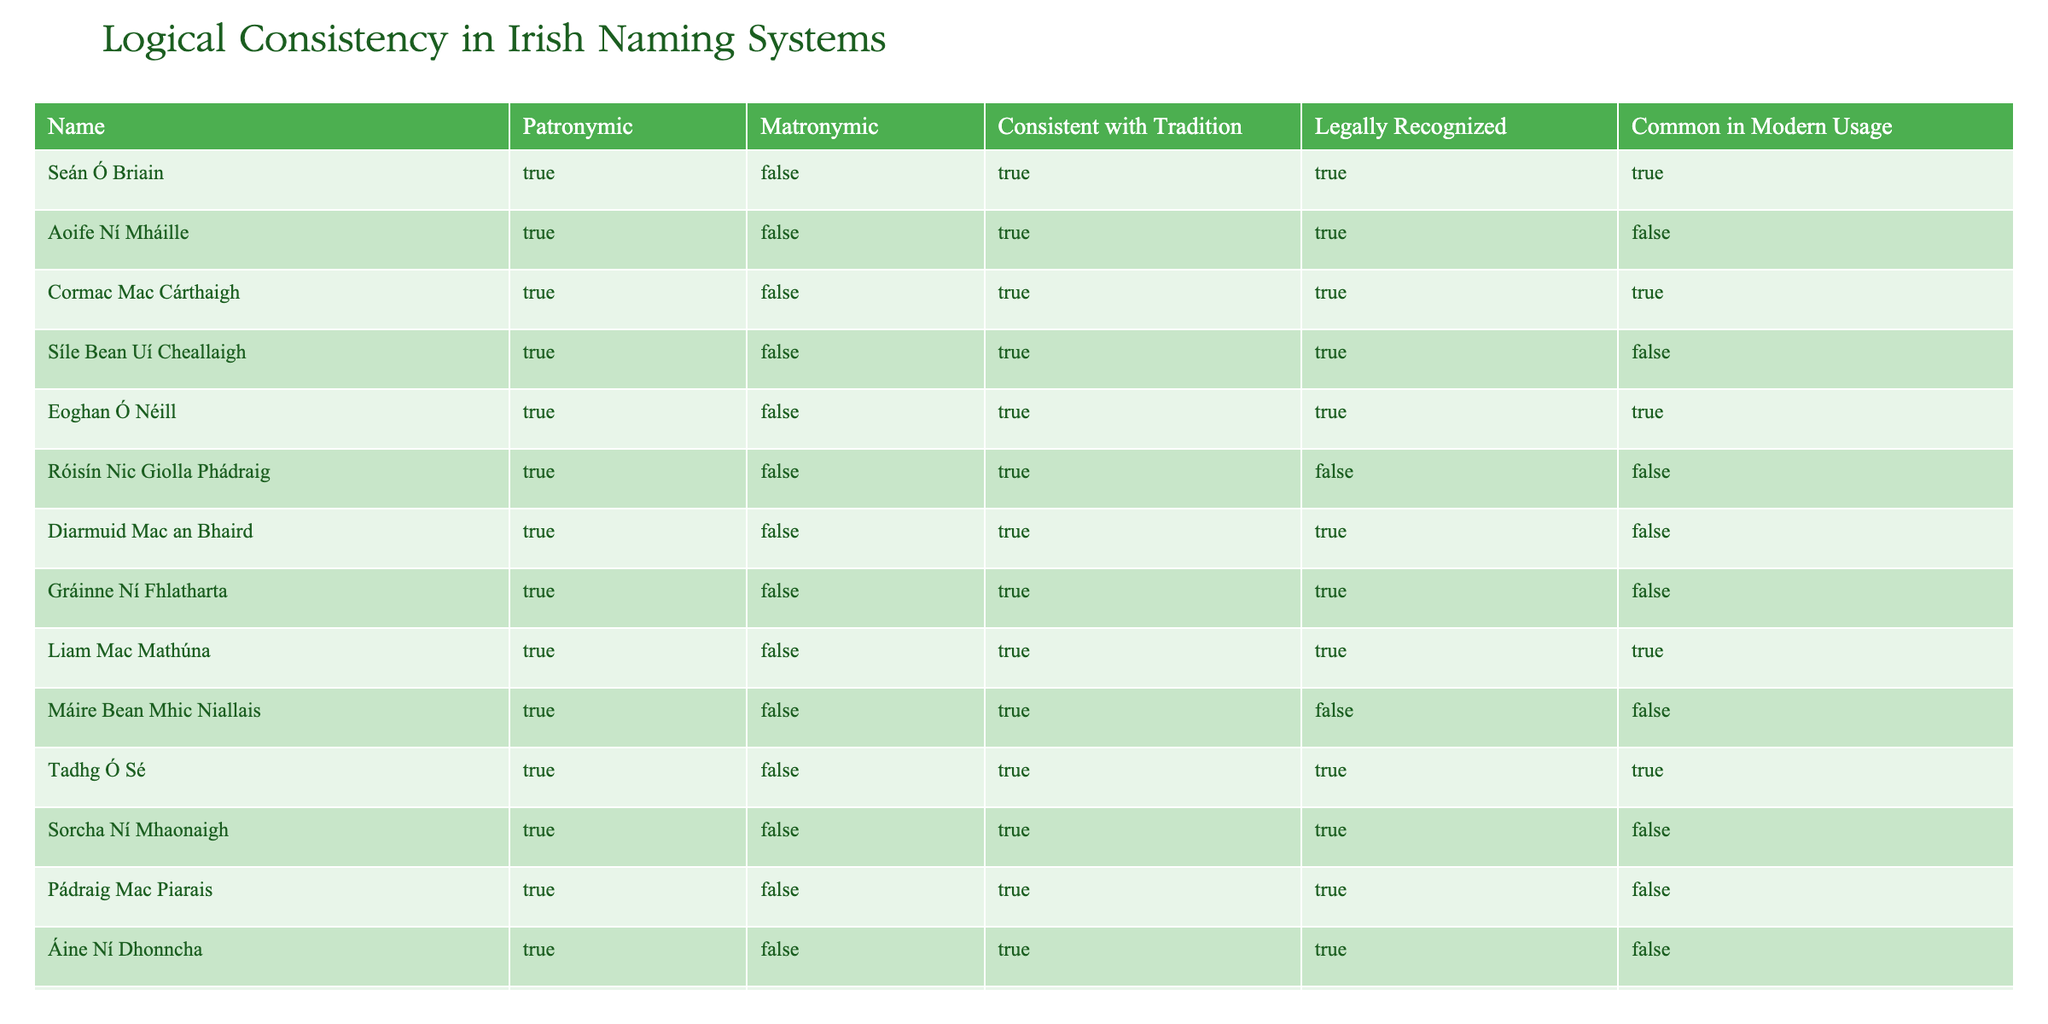What is the patronymic of Síle Bean Uí Cheallaigh? The table shows Síle Bean Uí Cheallaigh listed under the "Name" column, with its corresponding value under the "Patronymic" column marked as TRUE. Thus, the patronymic is true, confirming that this name follows the patronymic naming tradition.
Answer: TRUE How many names in the table are legally recognized? The "Legally Recognized" column contains TRUE for the following names: Seán Ó Briain, Cormac Mac Cárthaigh, Eoghan Ó Néill, Liam Mac Mathúna, Tadhg Ó Sé, Cathal Ó Searcaigh. There are a total of 6 rows where this is TRUE.
Answer: 6 Is Róisín Nic Giolla Phádraig consistent with tradition? By examining Róisín Nic Giolla Phádraig in the "Consistent with Tradition" column, which shows TRUE, we verify that this name is consistent with the traditional naming systems.
Answer: TRUE What is the commonality in modern usage of names associated with matronymics? If we look at the "Common in Modern Usage" column, the names associated with matronymics show FALSE for all names listed under this column, indicating they are not commonly used in contemporary contexts.
Answer: FALSE Which name has a patronymic that is legally recognized but not commonly used in modern context? We examine the "Legally Recognized" column and find names that are TRUE, such as Seán Ó Briain, Cormac Mac Cárthaigh, and others. The name Gráinne Ní Fhlatharta appears with TRUE in the legally recognized column but FALSE in modern usage, matching the criteria.
Answer: Gráinne Ní Fhlatharta If we count the names that are both consistent with tradition and legally recognized, how many are there? We check the "Consistent with Tradition" and "Legally Recognized" columns, where both conditions must be TRUE. The names Seán Ó Briain, Cormac Mac Cárthaigh, Eoghan Ó Néill, Liam Mac Mathúna, Tadhg Ó Sé, and Cathal Ó Searcaigh fit this requirement. This gives us a total of 6 names meeting both criteria.
Answer: 6 How many names are both matronymic and legally recognized? Upon checking the "Matronymic" column, all names are marked FALSE, meaning there are no names that qualify under this criterion. It leads us to conclude there are zero instances of matronymic names being legally recognized.
Answer: 0 What pattern can be observed regarding names that are consistent with tradition and those that are commonly used in modern context? We observe from the table that most names marked as consistent with tradition are also showing FALSE in modern usage, indicating a disconnect between traditional naming practices and their contemporary acceptance. This suggests a trend where older naming conventions are not often reflected in modern name choices.
Answer: Disconnect between tradition and modern usage 